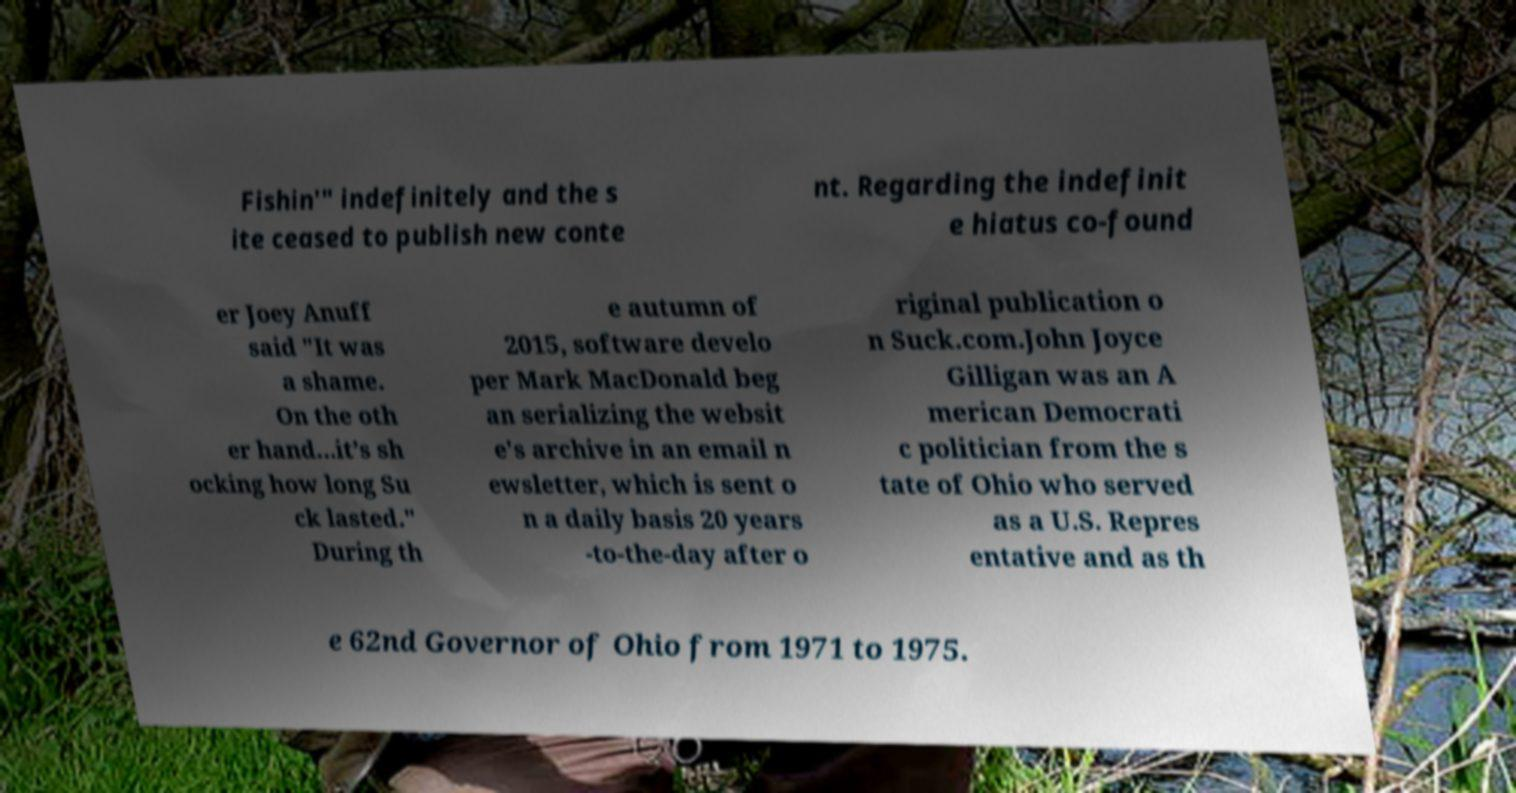There's text embedded in this image that I need extracted. Can you transcribe it verbatim? Fishin'" indefinitely and the s ite ceased to publish new conte nt. Regarding the indefinit e hiatus co-found er Joey Anuff said "It was a shame. On the oth er hand...it’s sh ocking how long Su ck lasted." During th e autumn of 2015, software develo per Mark MacDonald beg an serializing the websit e's archive in an email n ewsletter, which is sent o n a daily basis 20 years -to-the-day after o riginal publication o n Suck.com.John Joyce Gilligan was an A merican Democrati c politician from the s tate of Ohio who served as a U.S. Repres entative and as th e 62nd Governor of Ohio from 1971 to 1975. 